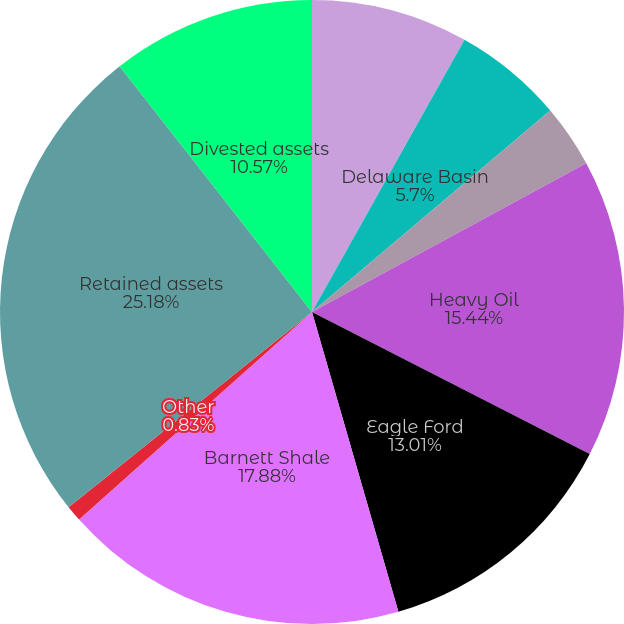Convert chart to OTSL. <chart><loc_0><loc_0><loc_500><loc_500><pie_chart><fcel>STACK<fcel>Delaware Basin<fcel>Rockies Oil<fcel>Heavy Oil<fcel>Eagle Ford<fcel>Barnett Shale<fcel>Other<fcel>Retained assets<fcel>Divested assets<nl><fcel>8.13%<fcel>5.7%<fcel>3.26%<fcel>15.44%<fcel>13.01%<fcel>17.88%<fcel>0.83%<fcel>25.19%<fcel>10.57%<nl></chart> 